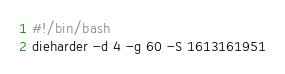<code> <loc_0><loc_0><loc_500><loc_500><_Bash_>#!/bin/bash
dieharder -d 4 -g 60 -S 1613161951
</code> 